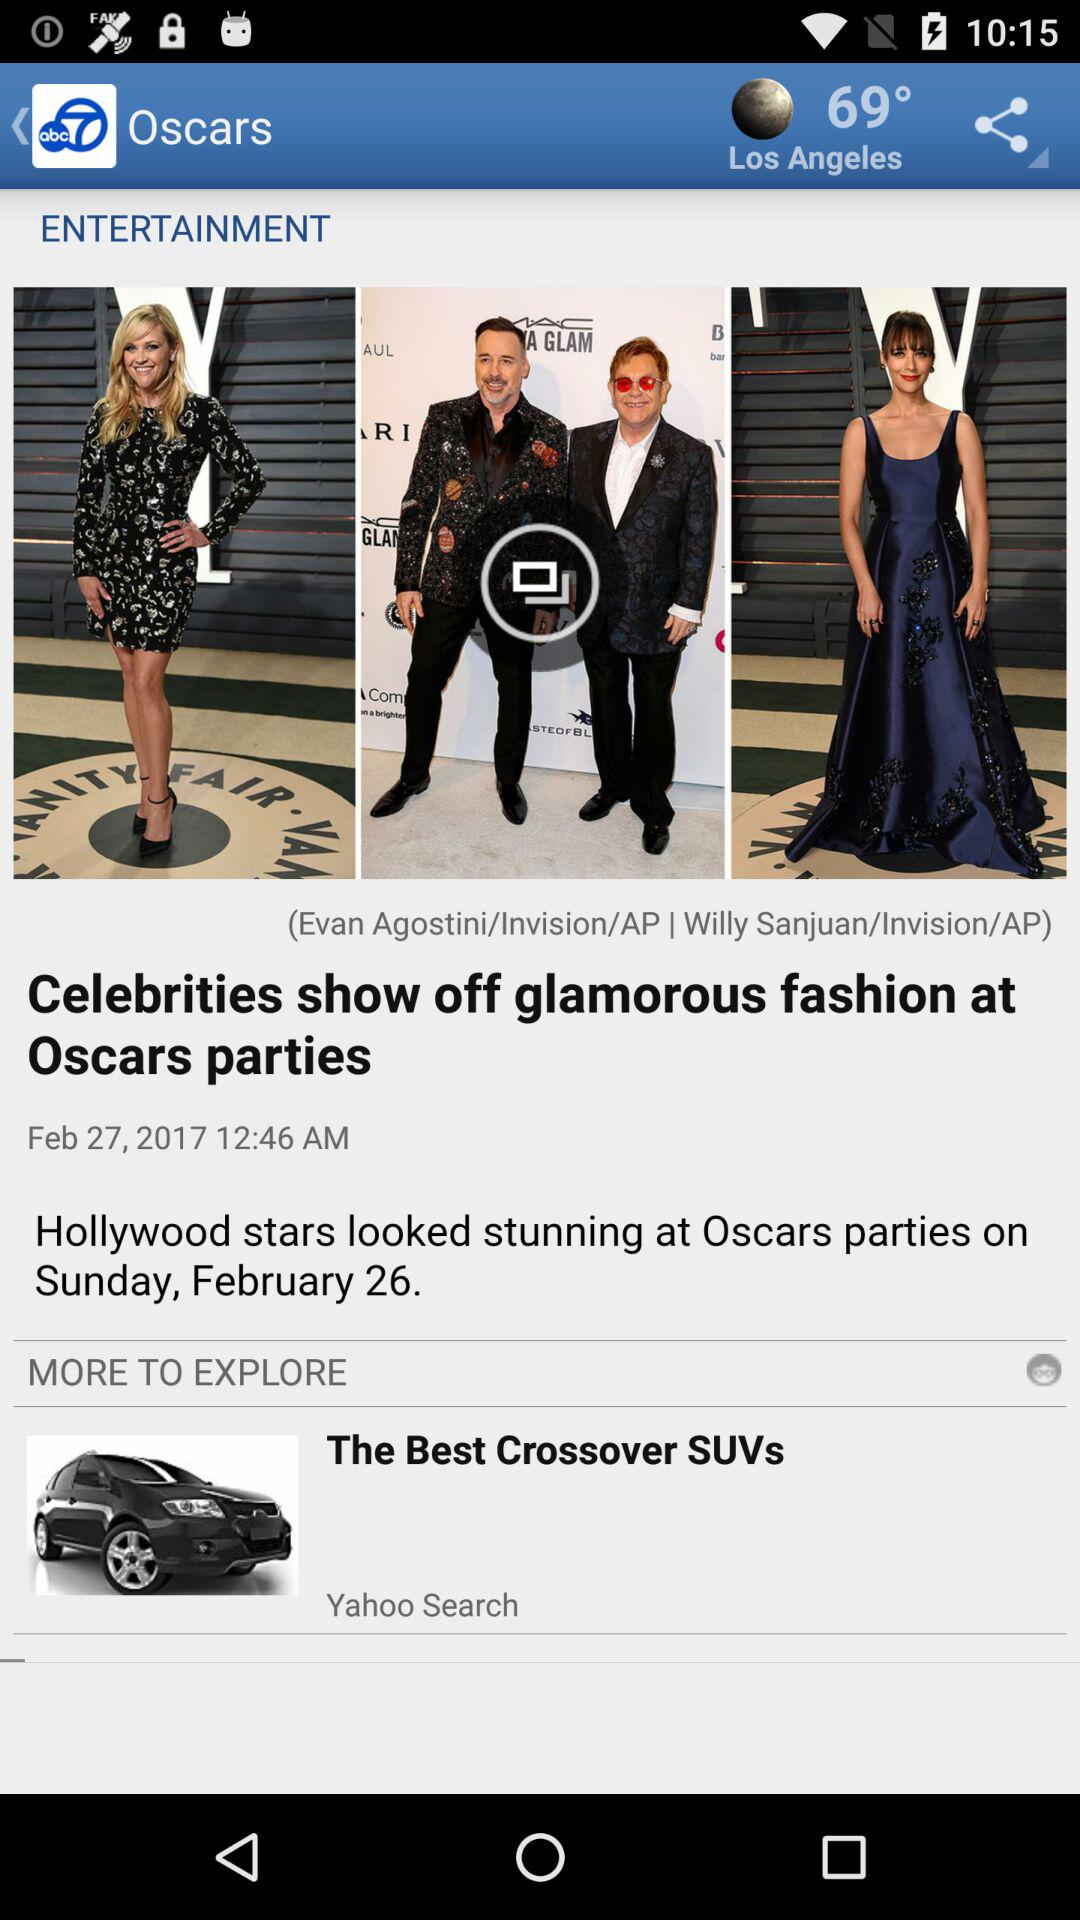What is the date? The dates are February 27, 2017 and Sunday, February 26. 